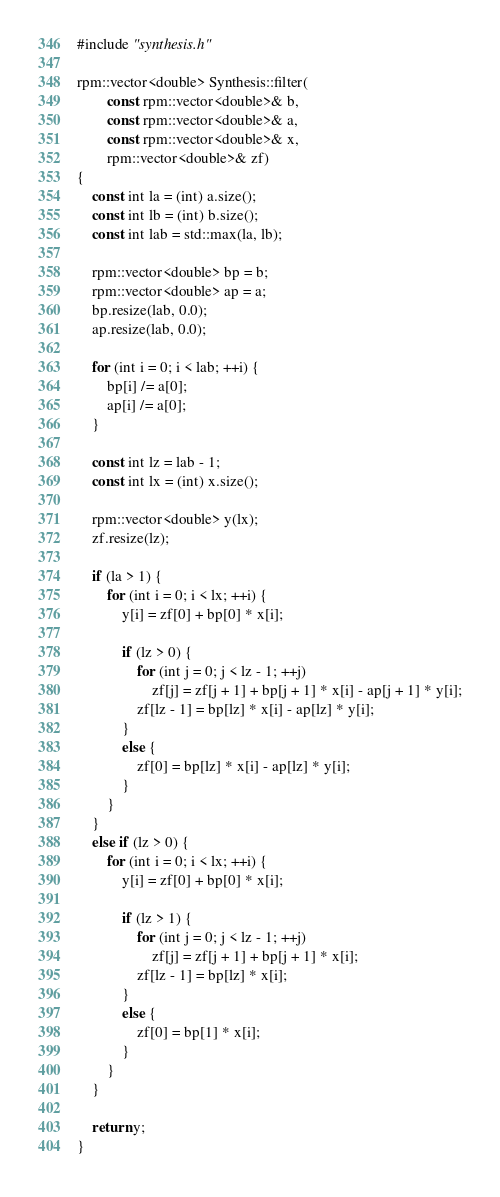<code> <loc_0><loc_0><loc_500><loc_500><_C++_>#include "synthesis.h"

rpm::vector<double> Synthesis::filter(
        const rpm::vector<double>& b,
        const rpm::vector<double>& a,
        const rpm::vector<double>& x,
        rpm::vector<double>& zf)
{
    const int la = (int) a.size();
    const int lb = (int) b.size();
    const int lab = std::max(la, lb);

    rpm::vector<double> bp = b;
    rpm::vector<double> ap = a;
    bp.resize(lab, 0.0);
    ap.resize(lab, 0.0);

    for (int i = 0; i < lab; ++i) {
        bp[i] /= a[0];
        ap[i] /= a[0];
    }

    const int lz = lab - 1;
    const int lx = (int) x.size();

    rpm::vector<double> y(lx);
    zf.resize(lz);

    if (la > 1) {
        for (int i = 0; i < lx; ++i) {
            y[i] = zf[0] + bp[0] * x[i];

            if (lz > 0) {
                for (int j = 0; j < lz - 1; ++j)
                    zf[j] = zf[j + 1] + bp[j + 1] * x[i] - ap[j + 1] * y[i];
                zf[lz - 1] = bp[lz] * x[i] - ap[lz] * y[i];
            }
            else {
                zf[0] = bp[lz] * x[i] - ap[lz] * y[i];
            }
        }
    }
    else if (lz > 0) {
        for (int i = 0; i < lx; ++i) {
            y[i] = zf[0] + bp[0] * x[i];

            if (lz > 1) {
                for (int j = 0; j < lz - 1; ++j)
                    zf[j] = zf[j + 1] + bp[j + 1] * x[i];
                zf[lz - 1] = bp[lz] * x[i];
            }
            else {
                zf[0] = bp[1] * x[i];
            }
        }
    }

    return y;
}

</code> 